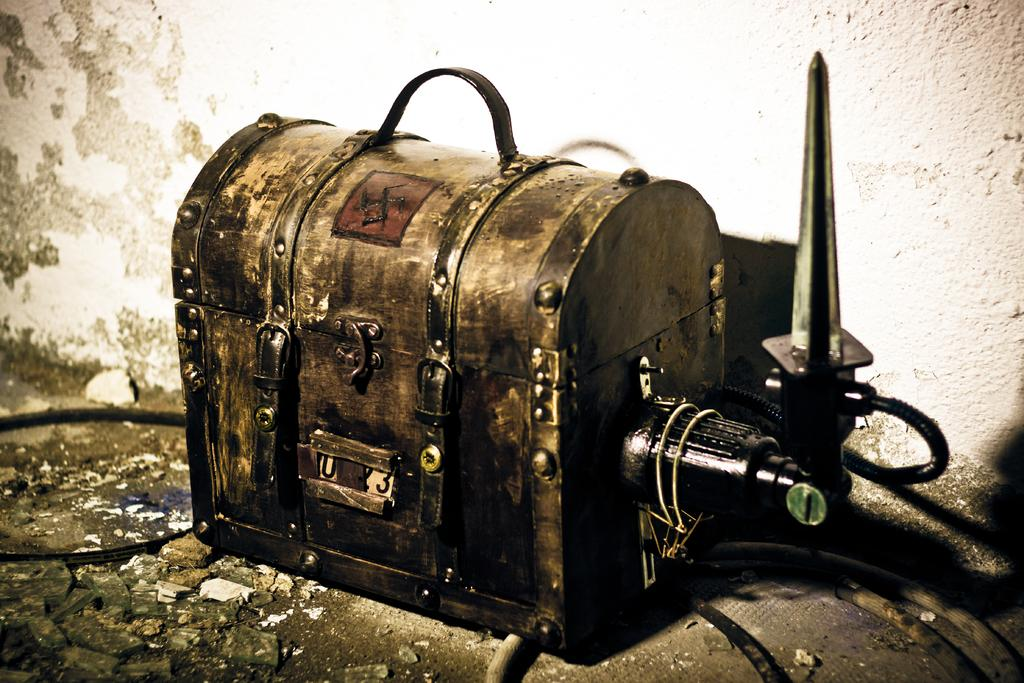What object is present in the image? There is a trunk in the image. Where is the trunk located? The trunk is placed on the floor. Is there any additional feature attached to the trunk? Yes, there is a pipe attached to the trunk. What type of invention can be seen in the image? There is no invention present in the image; it only features a trunk with a pipe attached. How many apples are visible in the image? There are no apples present in the image. 